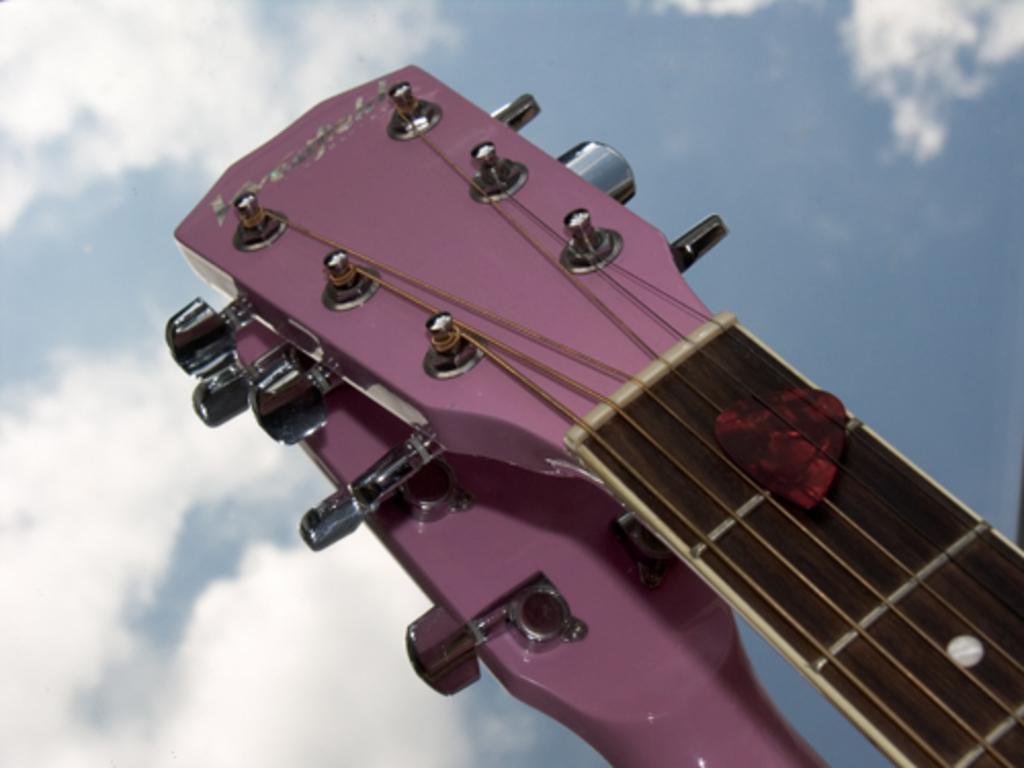Please provide a concise description of this image. In this picture we can see guitar straps and a heart shape symbol, wire and this are buttons and above this we can see sky with clouds. 